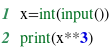<code> <loc_0><loc_0><loc_500><loc_500><_Python_>x=int(input())
print(x**3)
</code> 